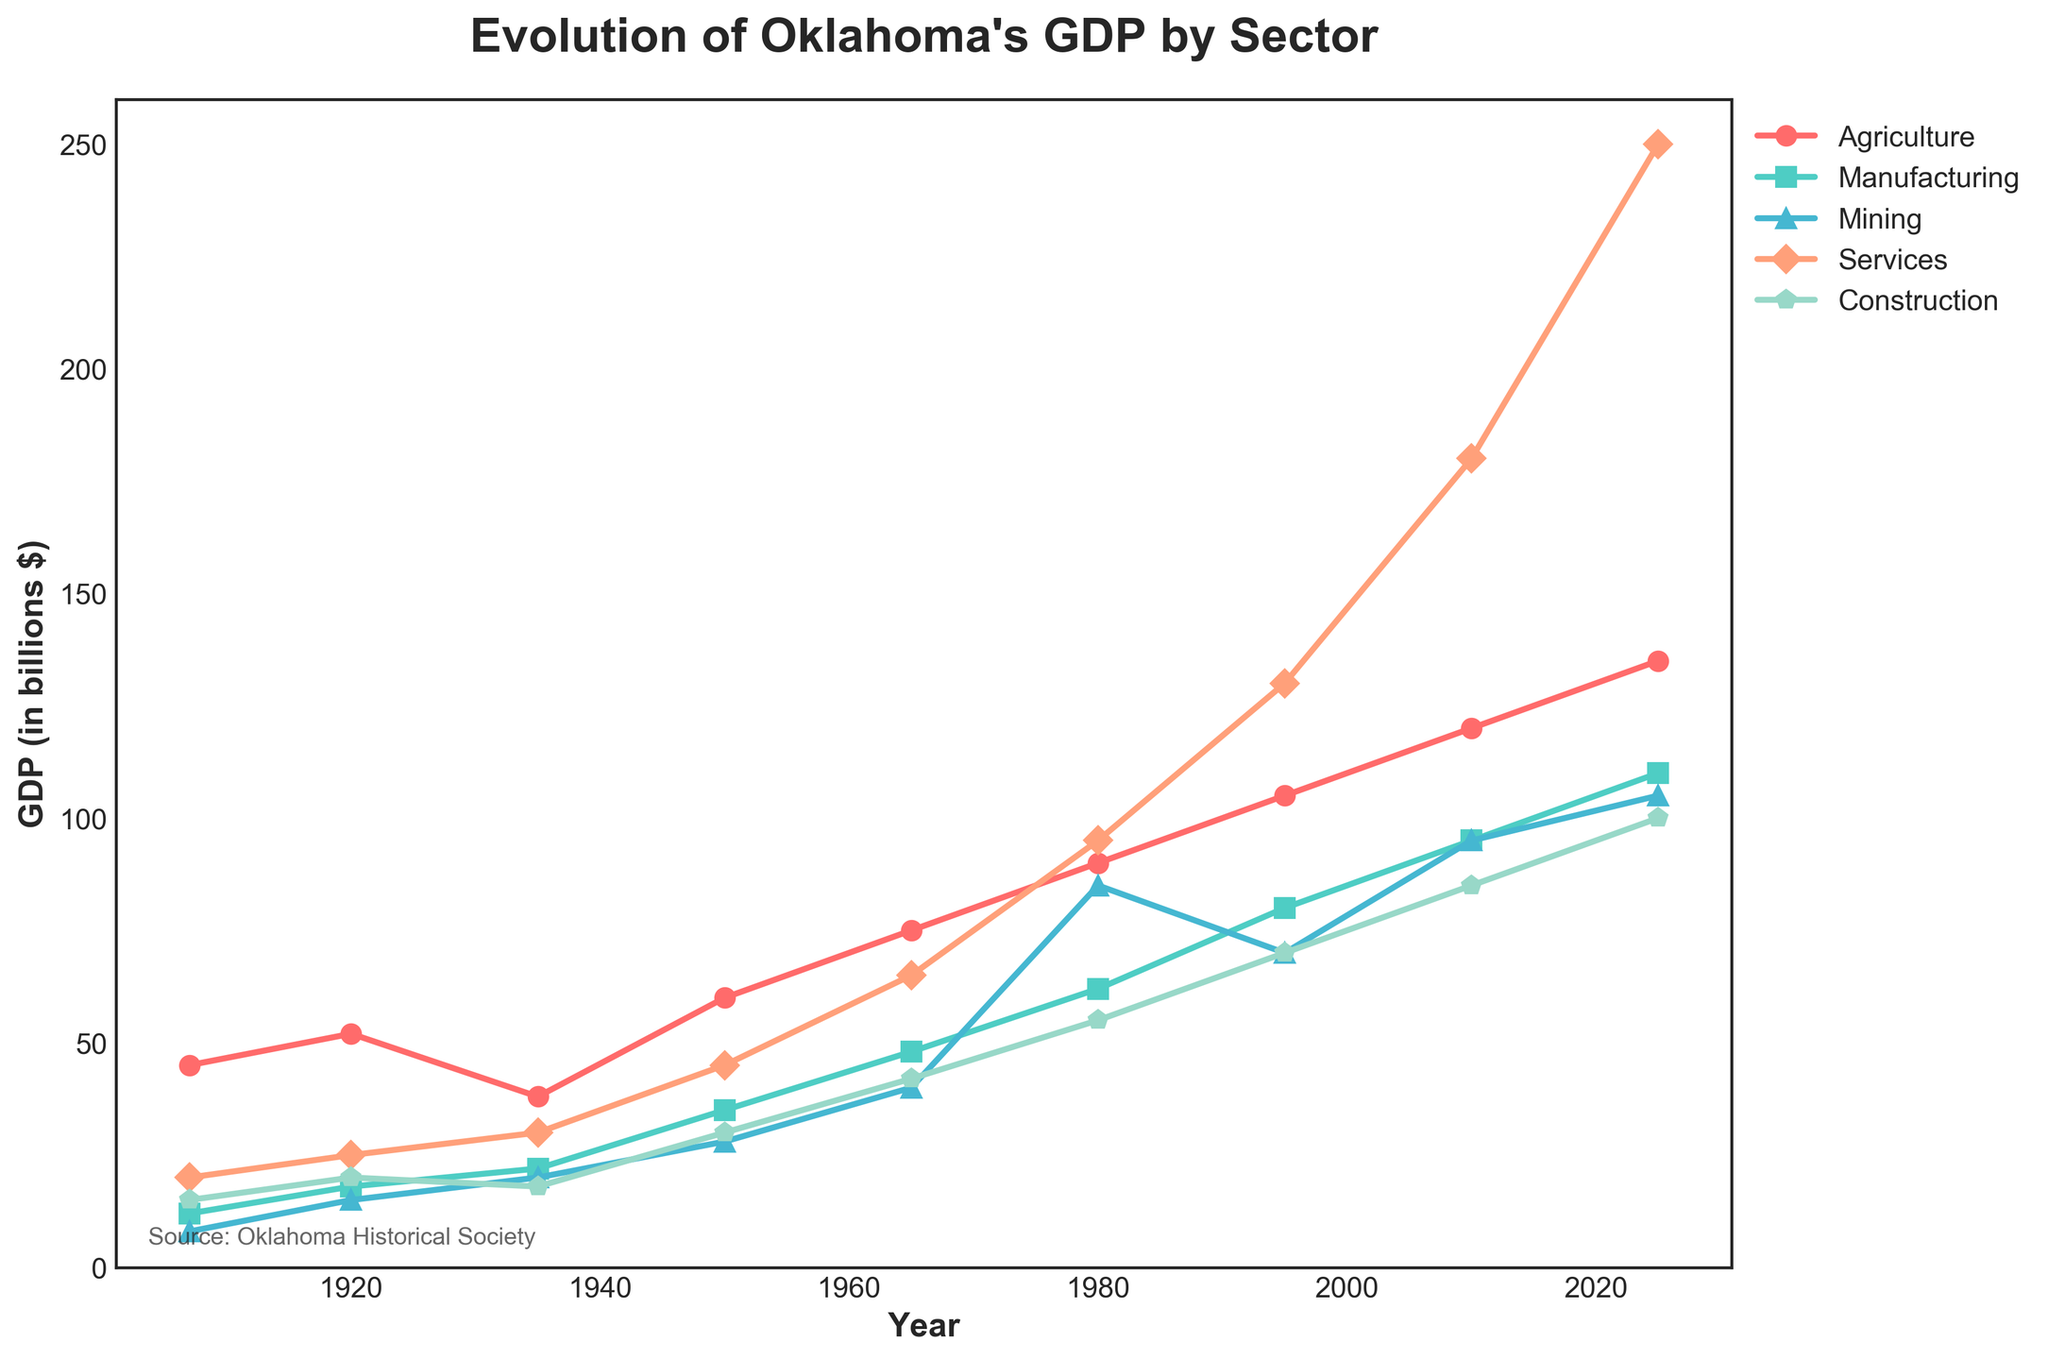which sector had the highest GDP in 2025? The chart shows that Services had the highest GDP in 2025, indicated by the tallest line at that year.
Answer: Services What is the trend in Agriculture from 1907 to 2025? The line corresponding to Agriculture shows a continuous increase from 1907 to 2025, indicating a consistent upward trend in GDP for this sector.
Answer: Increasing Which sectors' GDP in 1920 were equal? By examining the lines for 1920, Manufacturing and Construction both had a GDP value of 20 billion dollars, depicted by the markers at the same height.
Answer: Manufacturing and Construction How much did the GDP of Mining increase from 1950 to 1980? In 1950, Mining had a GDP of 28 billion dollars, and in 1980, it was 85 billion dollars. Calculating the difference, 85 - 28 = 57 billion dollars.
Answer: 57 billion dollars Compare the GDP growth of Services and Manufacturing between 1995 and 2025. The GDP of Services grew from 130 billion dollars in 1995 to 250 billion dollars in 2025, an increase of 120 billion dollars. The GDP of Manufacturing grew from 80 billion dollars in 1995 to 110 billion dollars in 2025, an increase of 30 billion dollars. The growth of Services is significantly higher.
Answer: Services grew more What was the overall GDP for all sectors combined in 2010? In 2010, the GDP values for all sectors are: Agriculture 120, Manufacturing 95, Mining 95, Services 180, Construction 85. Summing these values: 120 + 95 + 95 + 180 + 85 = 575 billion dollars.
Answer: 575 billion dollars Which sector had the least increase in GDP from 1907 to 2025? Calculating the increase for each sector: Agriculture (135-45=90), Manufacturing (110-12=98), Mining (105-8=97), Services (250-20=230), Construction (100-15=85). Construction had the smallest increase of 85 billion dollars.
Answer: Construction What can we infer about the economic focus of Oklahoma over time? The consistently rising GDP of all sectors, particularly the sharp increase in Services, suggests a diversified and increasingly service-oriented economy over time.
Answer: Increasingly service-oriented and diversified economy 